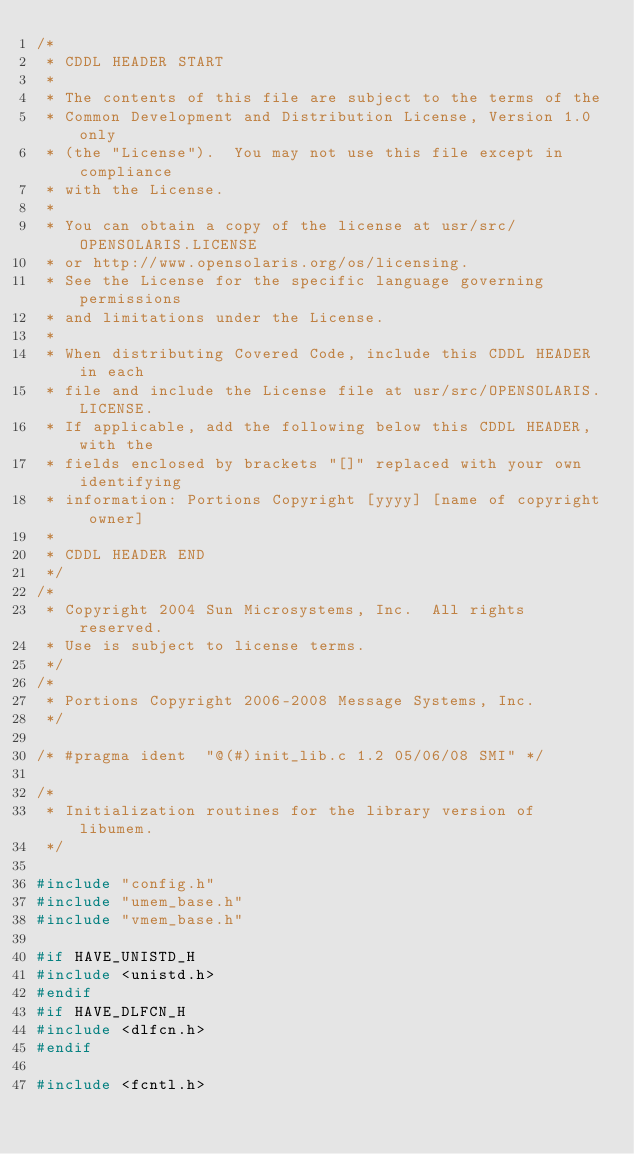Convert code to text. <code><loc_0><loc_0><loc_500><loc_500><_C_>/*
 * CDDL HEADER START
 *
 * The contents of this file are subject to the terms of the
 * Common Development and Distribution License, Version 1.0 only
 * (the "License").  You may not use this file except in compliance
 * with the License.
 *
 * You can obtain a copy of the license at usr/src/OPENSOLARIS.LICENSE
 * or http://www.opensolaris.org/os/licensing.
 * See the License for the specific language governing permissions
 * and limitations under the License.
 *
 * When distributing Covered Code, include this CDDL HEADER in each
 * file and include the License file at usr/src/OPENSOLARIS.LICENSE.
 * If applicable, add the following below this CDDL HEADER, with the
 * fields enclosed by brackets "[]" replaced with your own identifying
 * information: Portions Copyright [yyyy] [name of copyright owner]
 *
 * CDDL HEADER END
 */
/*
 * Copyright 2004 Sun Microsystems, Inc.  All rights reserved.
 * Use is subject to license terms.
 */
/*
 * Portions Copyright 2006-2008 Message Systems, Inc.
 */

/* #pragma ident	"@(#)init_lib.c	1.2	05/06/08 SMI" */

/*
 * Initialization routines for the library version of libumem.
 */

#include "config.h"
#include "umem_base.h"
#include "vmem_base.h"

#if HAVE_UNISTD_H
#include <unistd.h>
#endif
#if HAVE_DLFCN_H
#include <dlfcn.h>
#endif

#include <fcntl.h></code> 